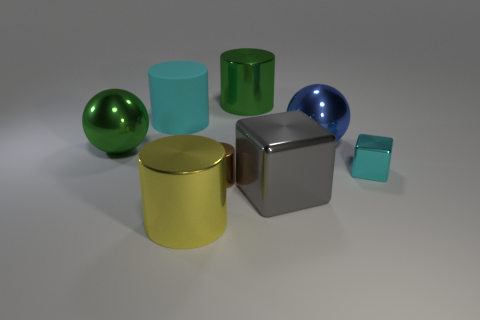What shape is the small shiny thing that is the same color as the large matte object? The small shiny object that shares its color with the large matte object is a cube. 